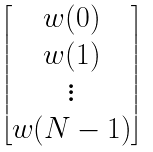Convert formula to latex. <formula><loc_0><loc_0><loc_500><loc_500>\begin{bmatrix} w ( 0 ) \\ w ( 1 ) \\ \vdots \\ w ( N - 1 ) \end{bmatrix}</formula> 